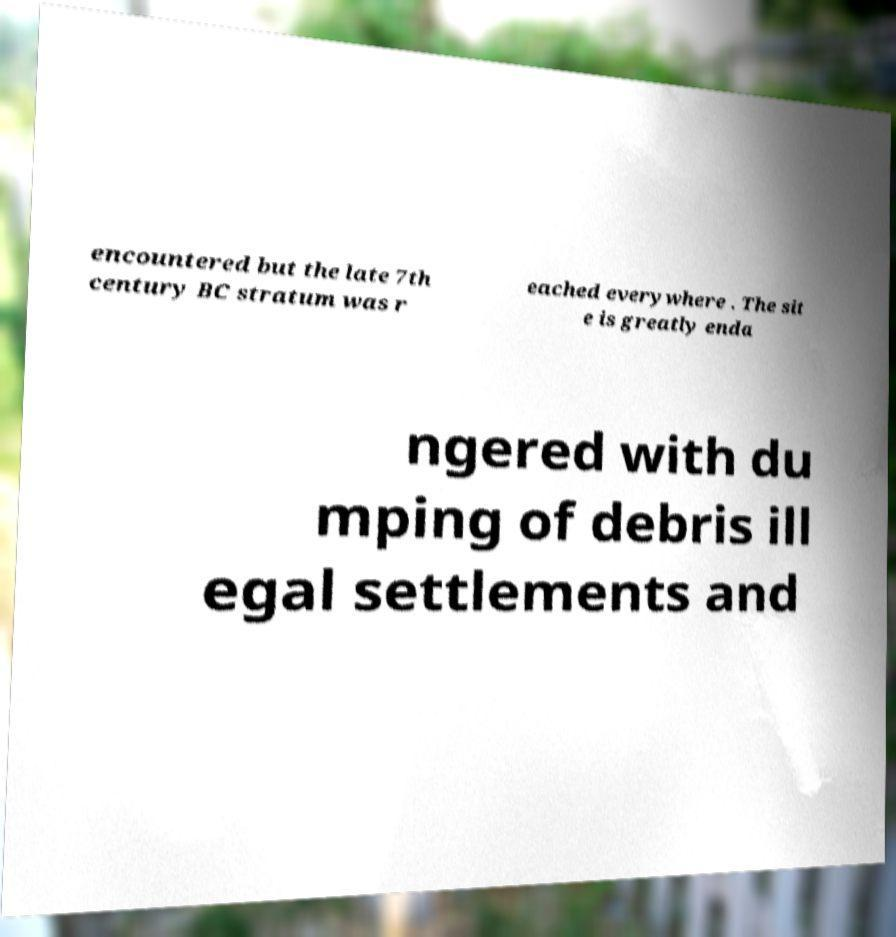I need the written content from this picture converted into text. Can you do that? encountered but the late 7th century BC stratum was r eached everywhere . The sit e is greatly enda ngered with du mping of debris ill egal settlements and 